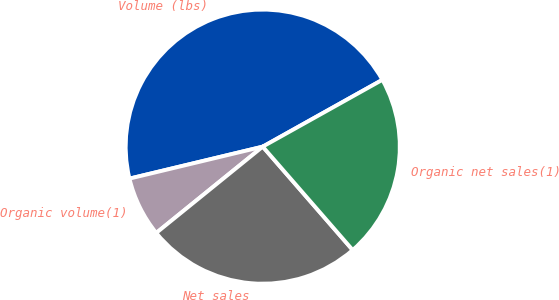Convert chart. <chart><loc_0><loc_0><loc_500><loc_500><pie_chart><fcel>Volume (lbs)<fcel>Organic volume(1)<fcel>Net sales<fcel>Organic net sales(1)<nl><fcel>45.64%<fcel>7.09%<fcel>25.56%<fcel>21.71%<nl></chart> 